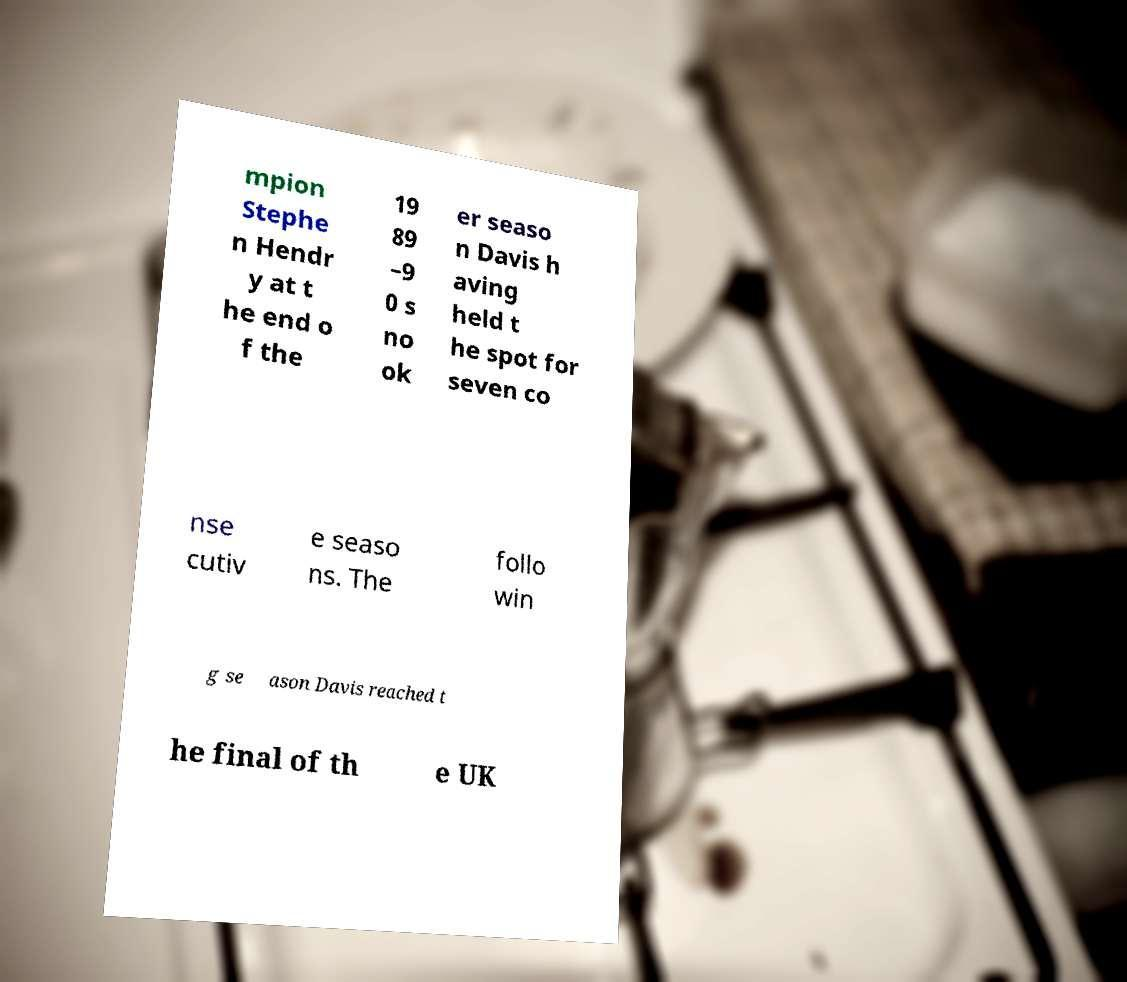Please read and relay the text visible in this image. What does it say? mpion Stephe n Hendr y at t he end o f the 19 89 –9 0 s no ok er seaso n Davis h aving held t he spot for seven co nse cutiv e seaso ns. The follo win g se ason Davis reached t he final of th e UK 